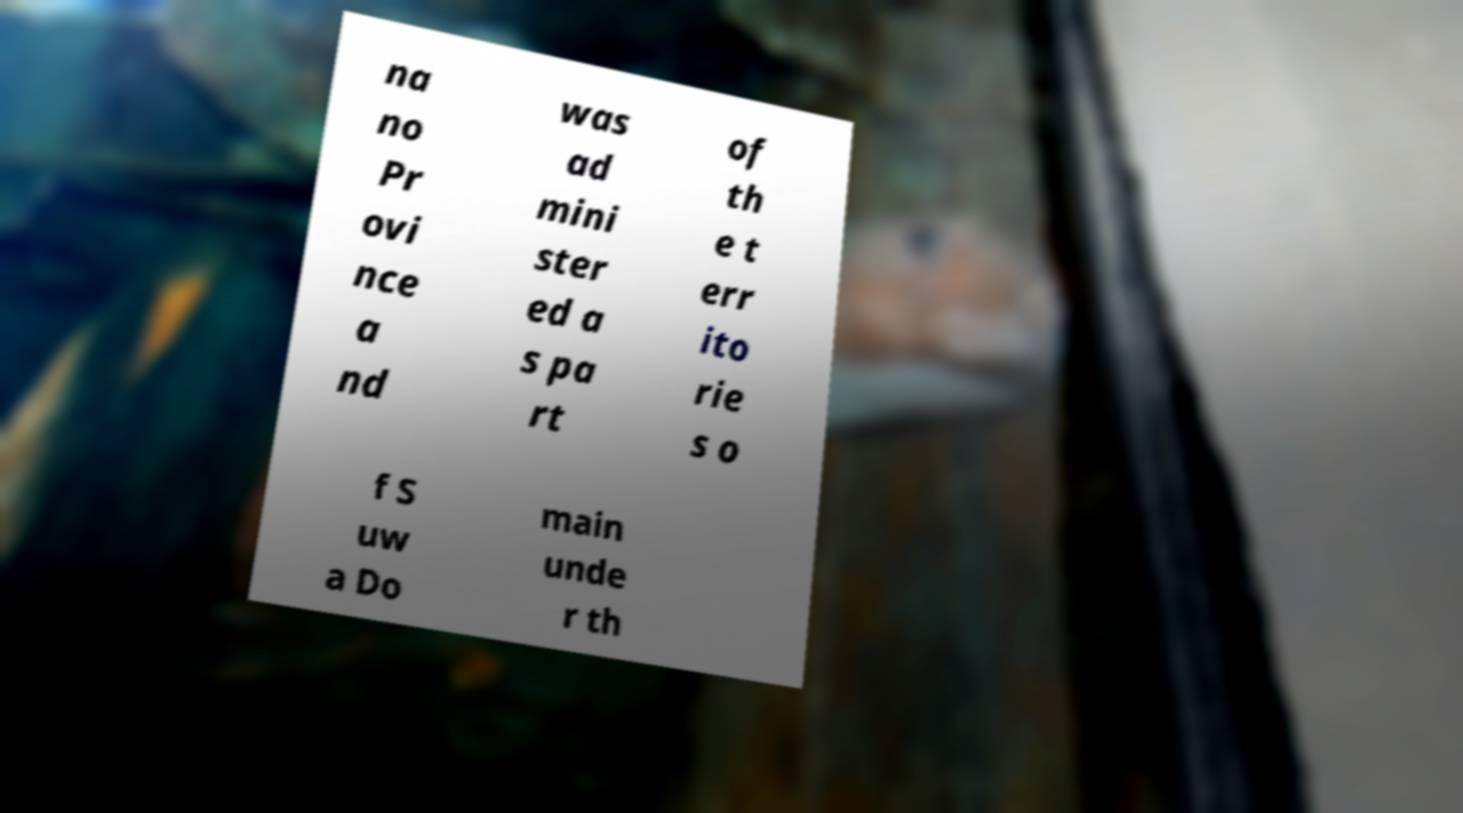Can you read and provide the text displayed in the image?This photo seems to have some interesting text. Can you extract and type it out for me? na no Pr ovi nce a nd was ad mini ster ed a s pa rt of th e t err ito rie s o f S uw a Do main unde r th 